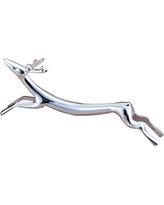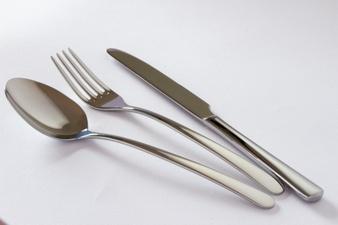The first image is the image on the left, the second image is the image on the right. Analyze the images presented: Is the assertion "Left image shows three utensils with barbell-shaped handles." valid? Answer yes or no. No. The first image is the image on the left, the second image is the image on the right. Analyze the images presented: Is the assertion "One image shows a matched set of knife, fork, and spoon utensils standing on end." valid? Answer yes or no. No. 